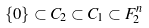<formula> <loc_0><loc_0><loc_500><loc_500>\{ 0 \} \subset C _ { 2 } \subset C _ { 1 } \subset F ^ { n } _ { 2 }</formula> 